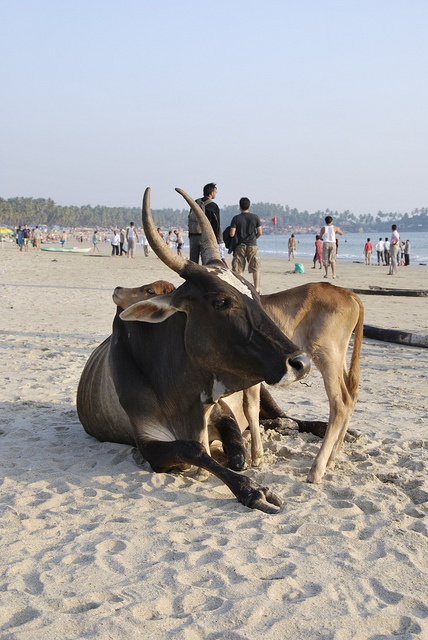Describe the objects in this image and their specific colors. I can see cow in lavender, black, gray, and maroon tones, cow in lavender, gray, and tan tones, people in lavender, darkgray, black, tan, and gray tones, people in lavender, black, gray, and tan tones, and people in lavender, gray, darkgray, lightgray, and tan tones in this image. 